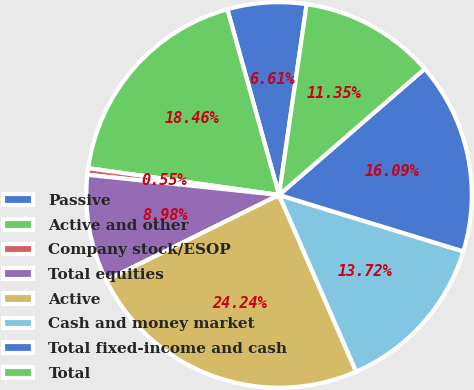Convert chart to OTSL. <chart><loc_0><loc_0><loc_500><loc_500><pie_chart><fcel>Passive<fcel>Active and other<fcel>Company stock/ESOP<fcel>Total equities<fcel>Active<fcel>Cash and money market<fcel>Total fixed-income and cash<fcel>Total<nl><fcel>6.61%<fcel>18.46%<fcel>0.55%<fcel>8.98%<fcel>24.24%<fcel>13.72%<fcel>16.09%<fcel>11.35%<nl></chart> 